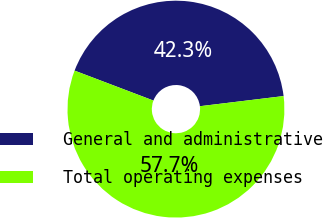Convert chart. <chart><loc_0><loc_0><loc_500><loc_500><pie_chart><fcel>General and administrative<fcel>Total operating expenses<nl><fcel>42.3%<fcel>57.7%<nl></chart> 